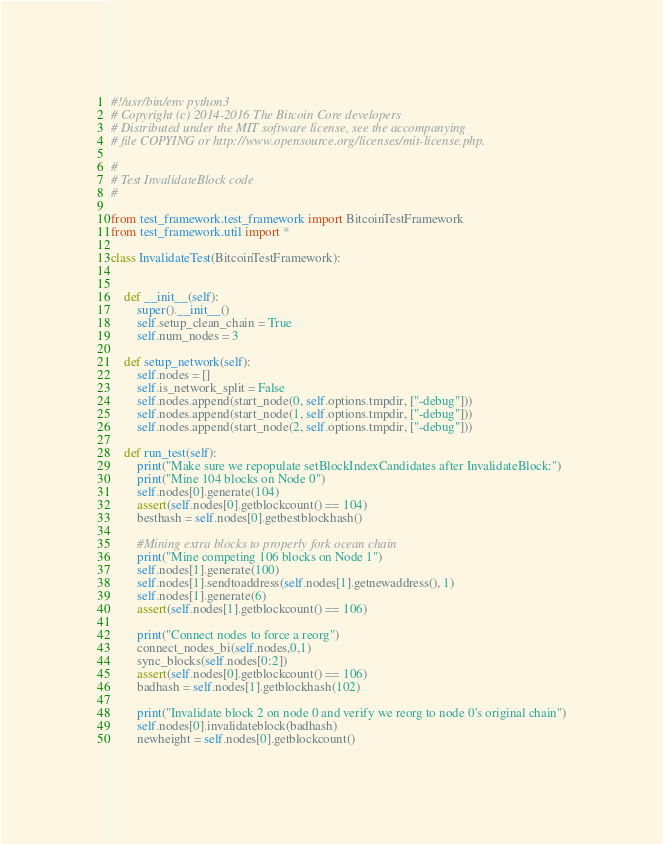Convert code to text. <code><loc_0><loc_0><loc_500><loc_500><_Python_>#!/usr/bin/env python3
# Copyright (c) 2014-2016 The Bitcoin Core developers
# Distributed under the MIT software license, see the accompanying
# file COPYING or http://www.opensource.org/licenses/mit-license.php.

#
# Test InvalidateBlock code
#

from test_framework.test_framework import BitcoinTestFramework
from test_framework.util import *

class InvalidateTest(BitcoinTestFramework):
    
        
    def __init__(self):
        super().__init__()
        self.setup_clean_chain = True
        self.num_nodes = 3

    def setup_network(self):
        self.nodes = []
        self.is_network_split = False 
        self.nodes.append(start_node(0, self.options.tmpdir, ["-debug"]))
        self.nodes.append(start_node(1, self.options.tmpdir, ["-debug"]))
        self.nodes.append(start_node(2, self.options.tmpdir, ["-debug"]))
        
    def run_test(self):
        print("Make sure we repopulate setBlockIndexCandidates after InvalidateBlock:")
        print("Mine 104 blocks on Node 0")
        self.nodes[0].generate(104)
        assert(self.nodes[0].getblockcount() == 104)
        besthash = self.nodes[0].getbestblockhash()

        #Mining extra blocks to properly fork ocean chain
        print("Mine competing 106 blocks on Node 1")
        self.nodes[1].generate(100)
        self.nodes[1].sendtoaddress(self.nodes[1].getnewaddress(), 1)
        self.nodes[1].generate(6)
        assert(self.nodes[1].getblockcount() == 106)

        print("Connect nodes to force a reorg")
        connect_nodes_bi(self.nodes,0,1)
        sync_blocks(self.nodes[0:2])
        assert(self.nodes[0].getblockcount() == 106)
        badhash = self.nodes[1].getblockhash(102)

        print("Invalidate block 2 on node 0 and verify we reorg to node 0's original chain")
        self.nodes[0].invalidateblock(badhash)
        newheight = self.nodes[0].getblockcount()</code> 